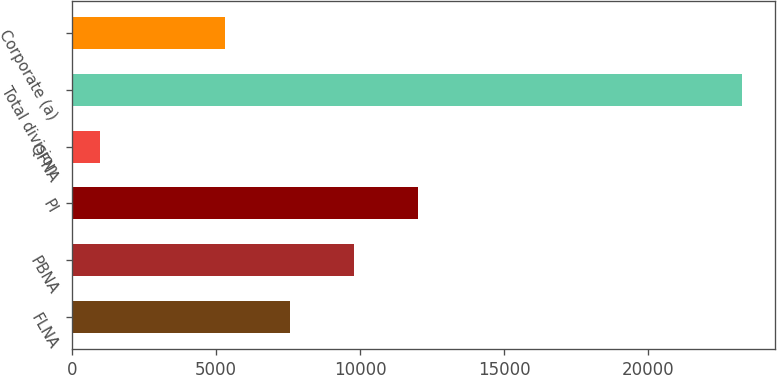Convert chart to OTSL. <chart><loc_0><loc_0><loc_500><loc_500><bar_chart><fcel>FLNA<fcel>PBNA<fcel>PI<fcel>QFNA<fcel>Total division<fcel>Corporate (a)<nl><fcel>7555.7<fcel>9780.4<fcel>12005.1<fcel>989<fcel>23236<fcel>5331<nl></chart> 